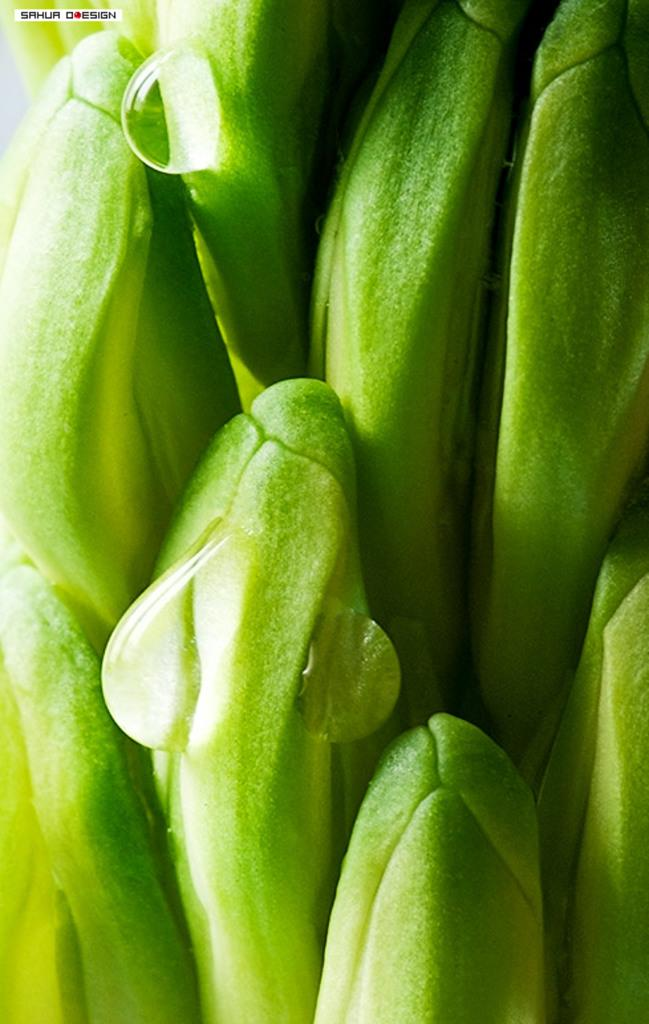What is present on the plant in the image? There are water drops on a plant in the image. Can you describe any additional elements in the image? Yes, there is some text in the top left corner of the image. What is the queen doing near the flame in the image? There is no queen or flame present in the image; it only features a plant with water drops and some text. 